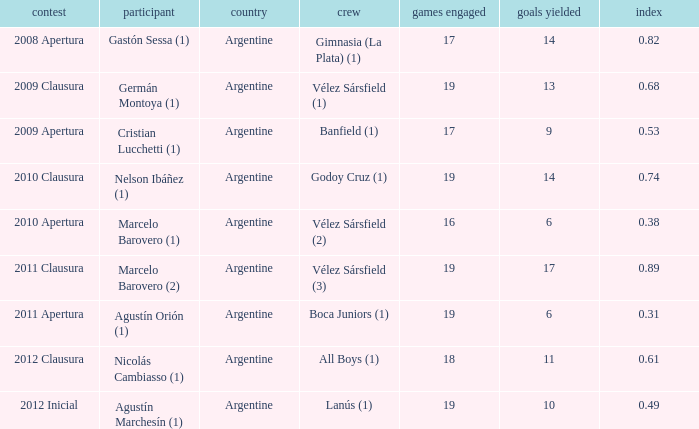Which team was in the 2012 clausura tournament? All Boys (1). 